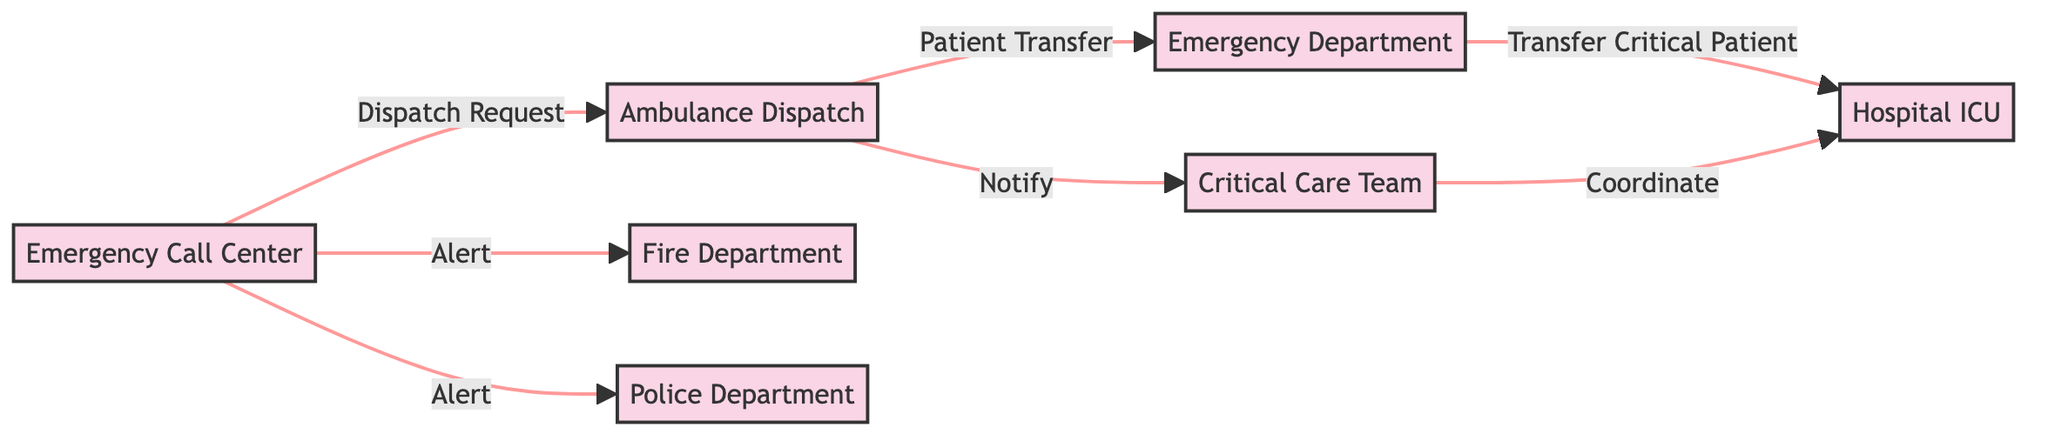What is the total number of nodes in the diagram? There are seven nodes in the diagram: Emergency Call Center, Ambulance Dispatch, Emergency Department, Critical Care Team, Hospital ICU, Fire Department, and Police Department.
Answer: 7 What relationship does the Emergency Call Center have with the Ambulance Dispatch? The Emergency Call Center sends a Dispatch Request to the Ambulance Dispatch. This relationship is identified by the directed edge labeled "Dispatch Request" connecting these two nodes.
Answer: Dispatch Request Which entities are alerted by the Emergency Call Center? The Emergency Call Center alerts both the Fire Department and the Police Department, as shown by the edges leading from the Call Center to each of those nodes labelled "Alert."
Answer: Fire Department and Police Department What is the transfer flow for patients from the Ambulance Dispatch? The flow starts at the Ambulance Dispatch, which has a directed edge indicating a Patient Transfer to the Emergency Department and also notifies the Critical Care Team.
Answer: Emergency Department and Critical Care Team How many distinct alerts does the Emergency Call Center issue? The Emergency Call Center issues two distinct alerts, one to the Fire Department and the other to the Police Department. Each of these relationships is represented by an edge labelled "Alert."
Answer: 2 What action does the Critical Care Team take regarding the Hospital ICU? The Critical Care Team coordinates with the Hospital ICU, as shown by the directed edge labelled "Coordinate." This means they work together in managing patient care after a transfer.
Answer: Coordinate Which node is the end destination for critical patient transfers? The Hospital ICU is the end destination for critical patient transfers, indicated by the edge from the Emergency Department labelled "Transfer Critical Patient."
Answer: Hospital ICU What is the primary purpose of the edges emanating from the Ambulance Dispatch? The edges from the Ambulance Dispatch represent the actions taken after receiving a dispatch request, specifically transferring a patient to the Emergency Department and notifying the Critical Care Team.
Answer: Patient Transfer and Notify 